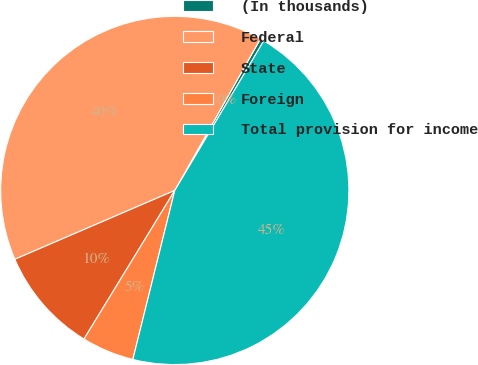<chart> <loc_0><loc_0><loc_500><loc_500><pie_chart><fcel>(In thousands)<fcel>Federal<fcel>State<fcel>Foreign<fcel>Total provision for income<nl><fcel>0.36%<fcel>39.65%<fcel>9.8%<fcel>4.86%<fcel>45.33%<nl></chart> 